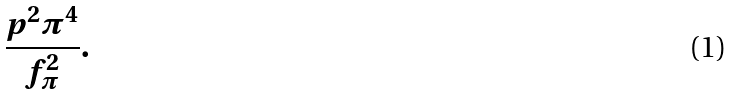<formula> <loc_0><loc_0><loc_500><loc_500>\frac { p ^ { 2 } \pi ^ { 4 } } { f _ { \pi } ^ { 2 } } .</formula> 